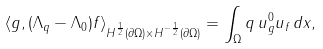Convert formula to latex. <formula><loc_0><loc_0><loc_500><loc_500>\langle g , ( \Lambda _ { q } - \Lambda _ { 0 } ) f \rangle _ { { H ^ { \frac { 1 } { 2 } } ( \partial \Omega ) \times H ^ { - \frac { 1 } { 2 } } ( \partial \Omega ) } } = \int _ { \Omega } q \, u ^ { 0 } _ { g } u _ { f } \, d x ,</formula> 